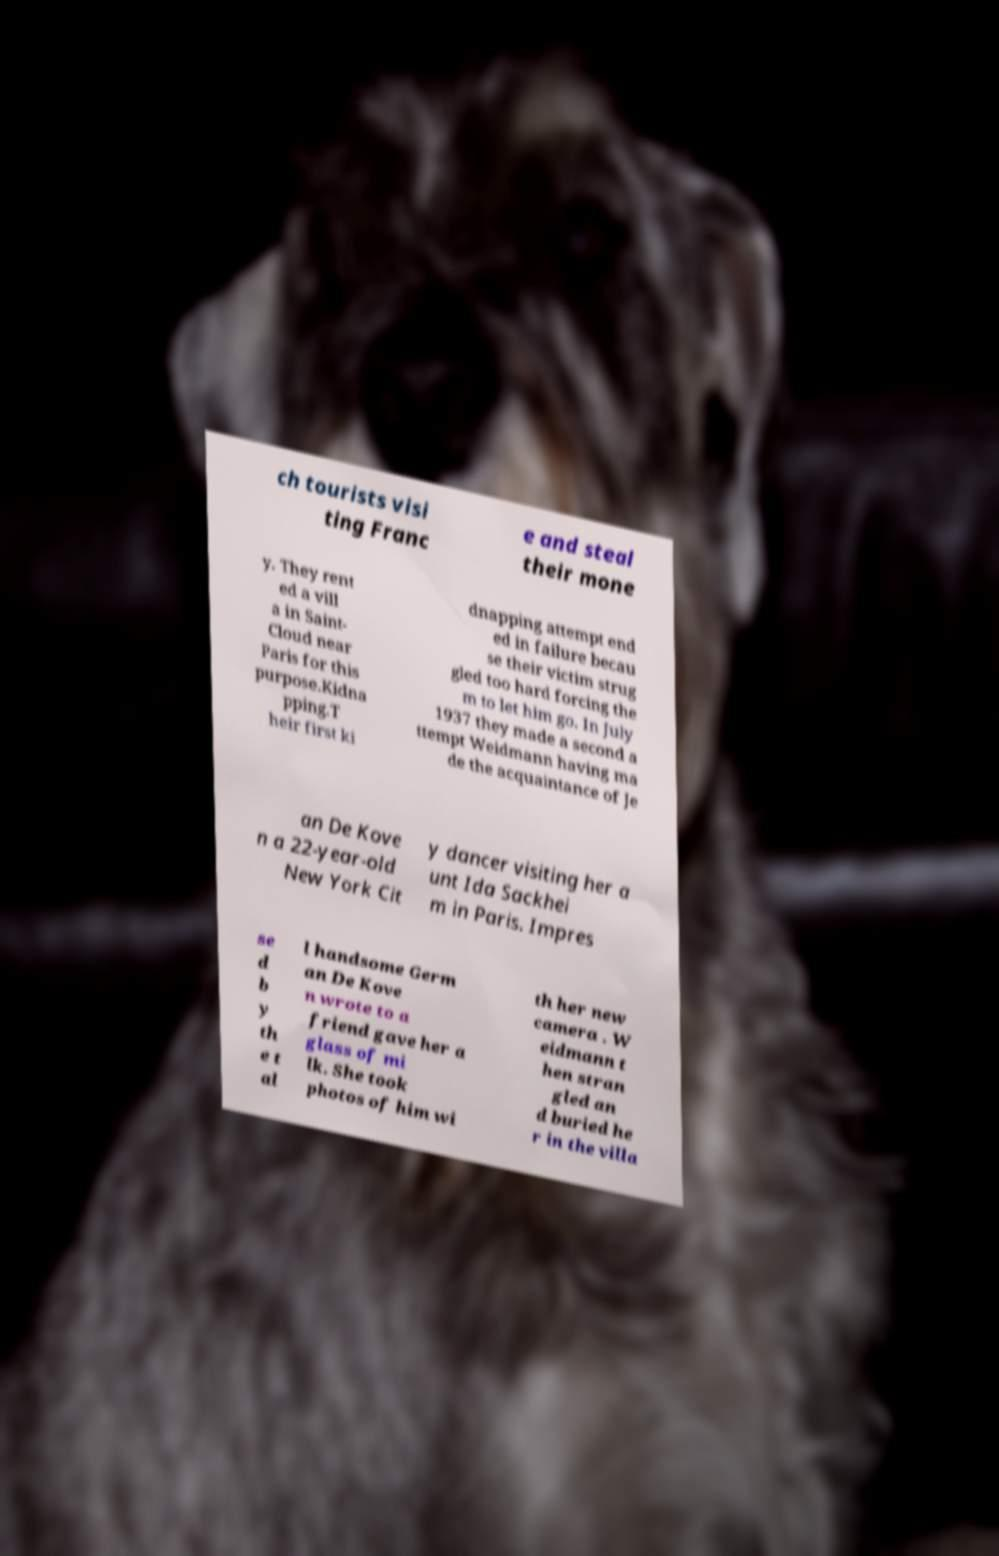Can you read and provide the text displayed in the image?This photo seems to have some interesting text. Can you extract and type it out for me? ch tourists visi ting Franc e and steal their mone y. They rent ed a vill a in Saint- Cloud near Paris for this purpose.Kidna pping.T heir first ki dnapping attempt end ed in failure becau se their victim strug gled too hard forcing the m to let him go. In July 1937 they made a second a ttempt Weidmann having ma de the acquaintance of Je an De Kove n a 22-year-old New York Cit y dancer visiting her a unt Ida Sackhei m in Paris. Impres se d b y th e t al l handsome Germ an De Kove n wrote to a friend gave her a glass of mi lk. She took photos of him wi th her new camera . W eidmann t hen stran gled an d buried he r in the villa 